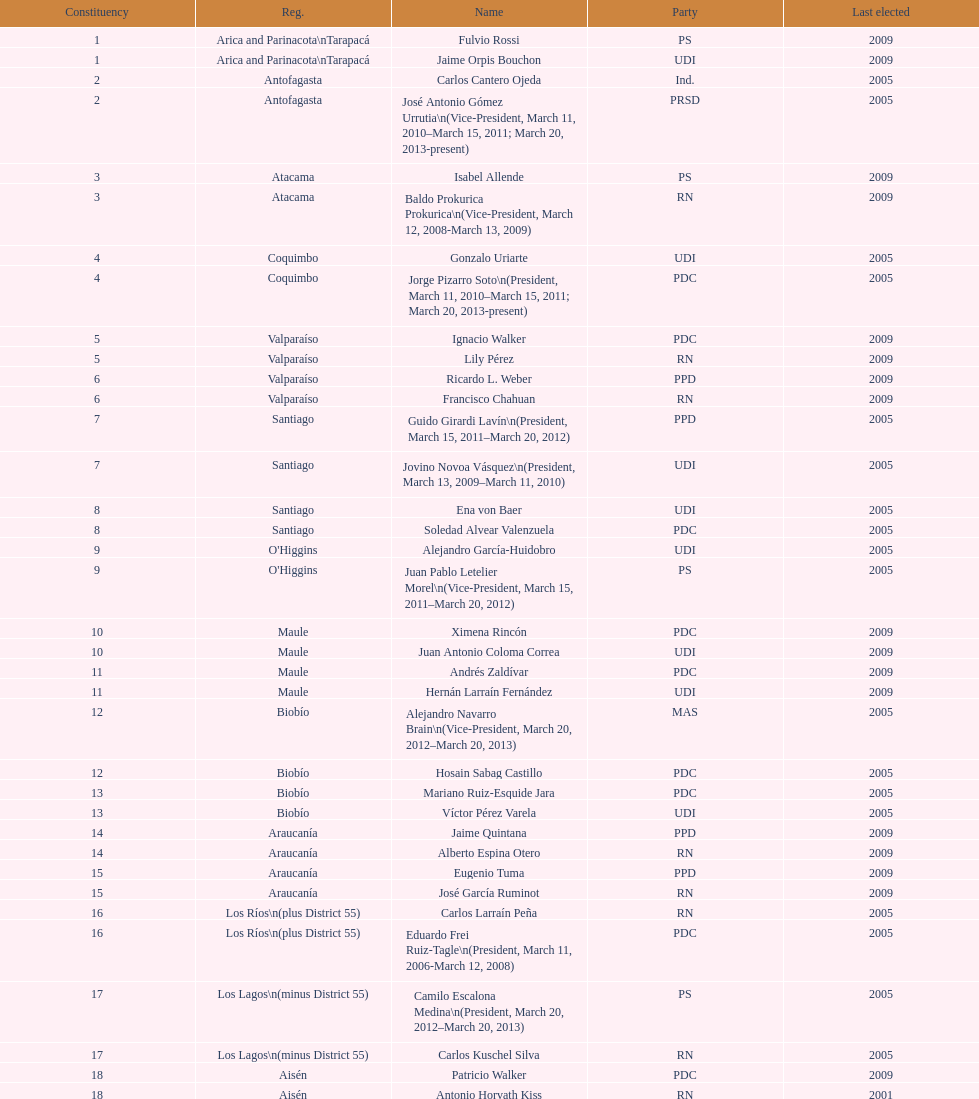What is the last region listed on the table? Magallanes. 